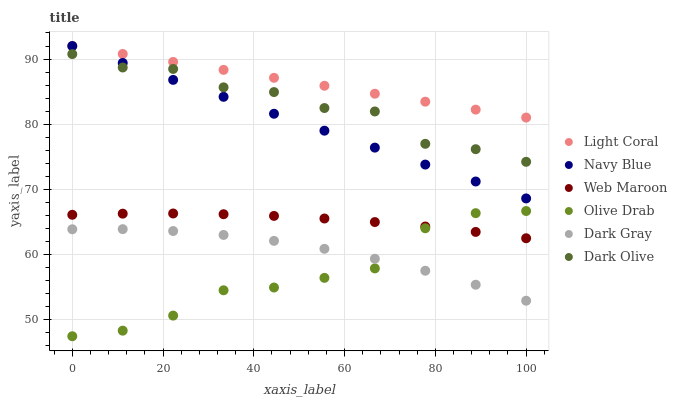Does Olive Drab have the minimum area under the curve?
Answer yes or no. Yes. Does Light Coral have the maximum area under the curve?
Answer yes or no. Yes. Does Navy Blue have the minimum area under the curve?
Answer yes or no. No. Does Navy Blue have the maximum area under the curve?
Answer yes or no. No. Is Navy Blue the smoothest?
Answer yes or no. Yes. Is Dark Olive the roughest?
Answer yes or no. Yes. Is Dark Olive the smoothest?
Answer yes or no. No. Is Navy Blue the roughest?
Answer yes or no. No. Does Olive Drab have the lowest value?
Answer yes or no. Yes. Does Navy Blue have the lowest value?
Answer yes or no. No. Does Light Coral have the highest value?
Answer yes or no. Yes. Does Dark Olive have the highest value?
Answer yes or no. No. Is Dark Gray less than Dark Olive?
Answer yes or no. Yes. Is Light Coral greater than Dark Gray?
Answer yes or no. Yes. Does Dark Olive intersect Navy Blue?
Answer yes or no. Yes. Is Dark Olive less than Navy Blue?
Answer yes or no. No. Is Dark Olive greater than Navy Blue?
Answer yes or no. No. Does Dark Gray intersect Dark Olive?
Answer yes or no. No. 